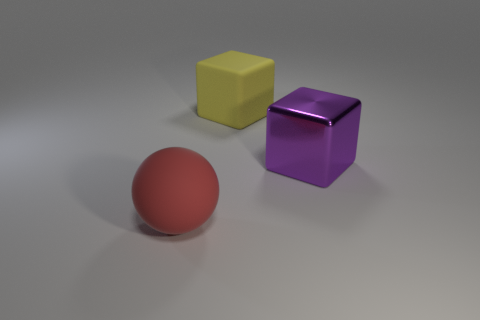Add 1 big matte objects. How many objects exist? 4 Subtract all balls. How many objects are left? 2 Subtract 0 yellow balls. How many objects are left? 3 Subtract all spheres. Subtract all big purple shiny things. How many objects are left? 1 Add 2 yellow matte cubes. How many yellow matte cubes are left? 3 Add 2 big red things. How many big red things exist? 3 